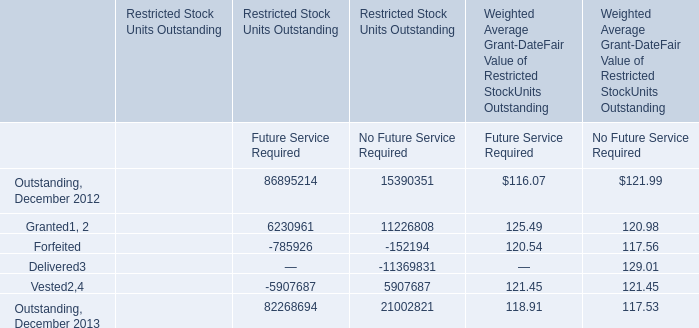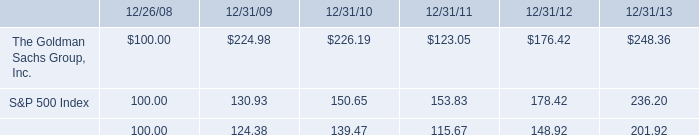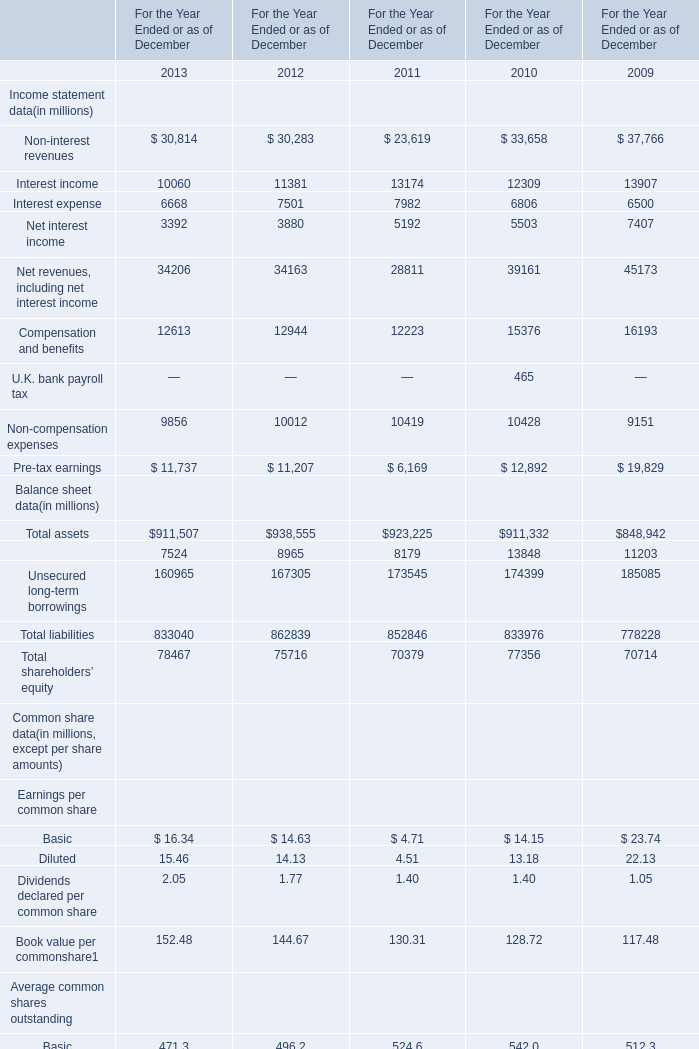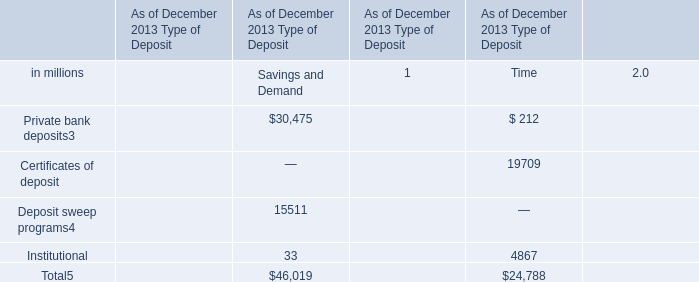What's the sum of the Total assets for Balance sheet data in the years where Future Service Required for Restricted Stock Units Outstanding is positive? (in million) 
Computations: (911507 + 938555)
Answer: 1850062.0. 